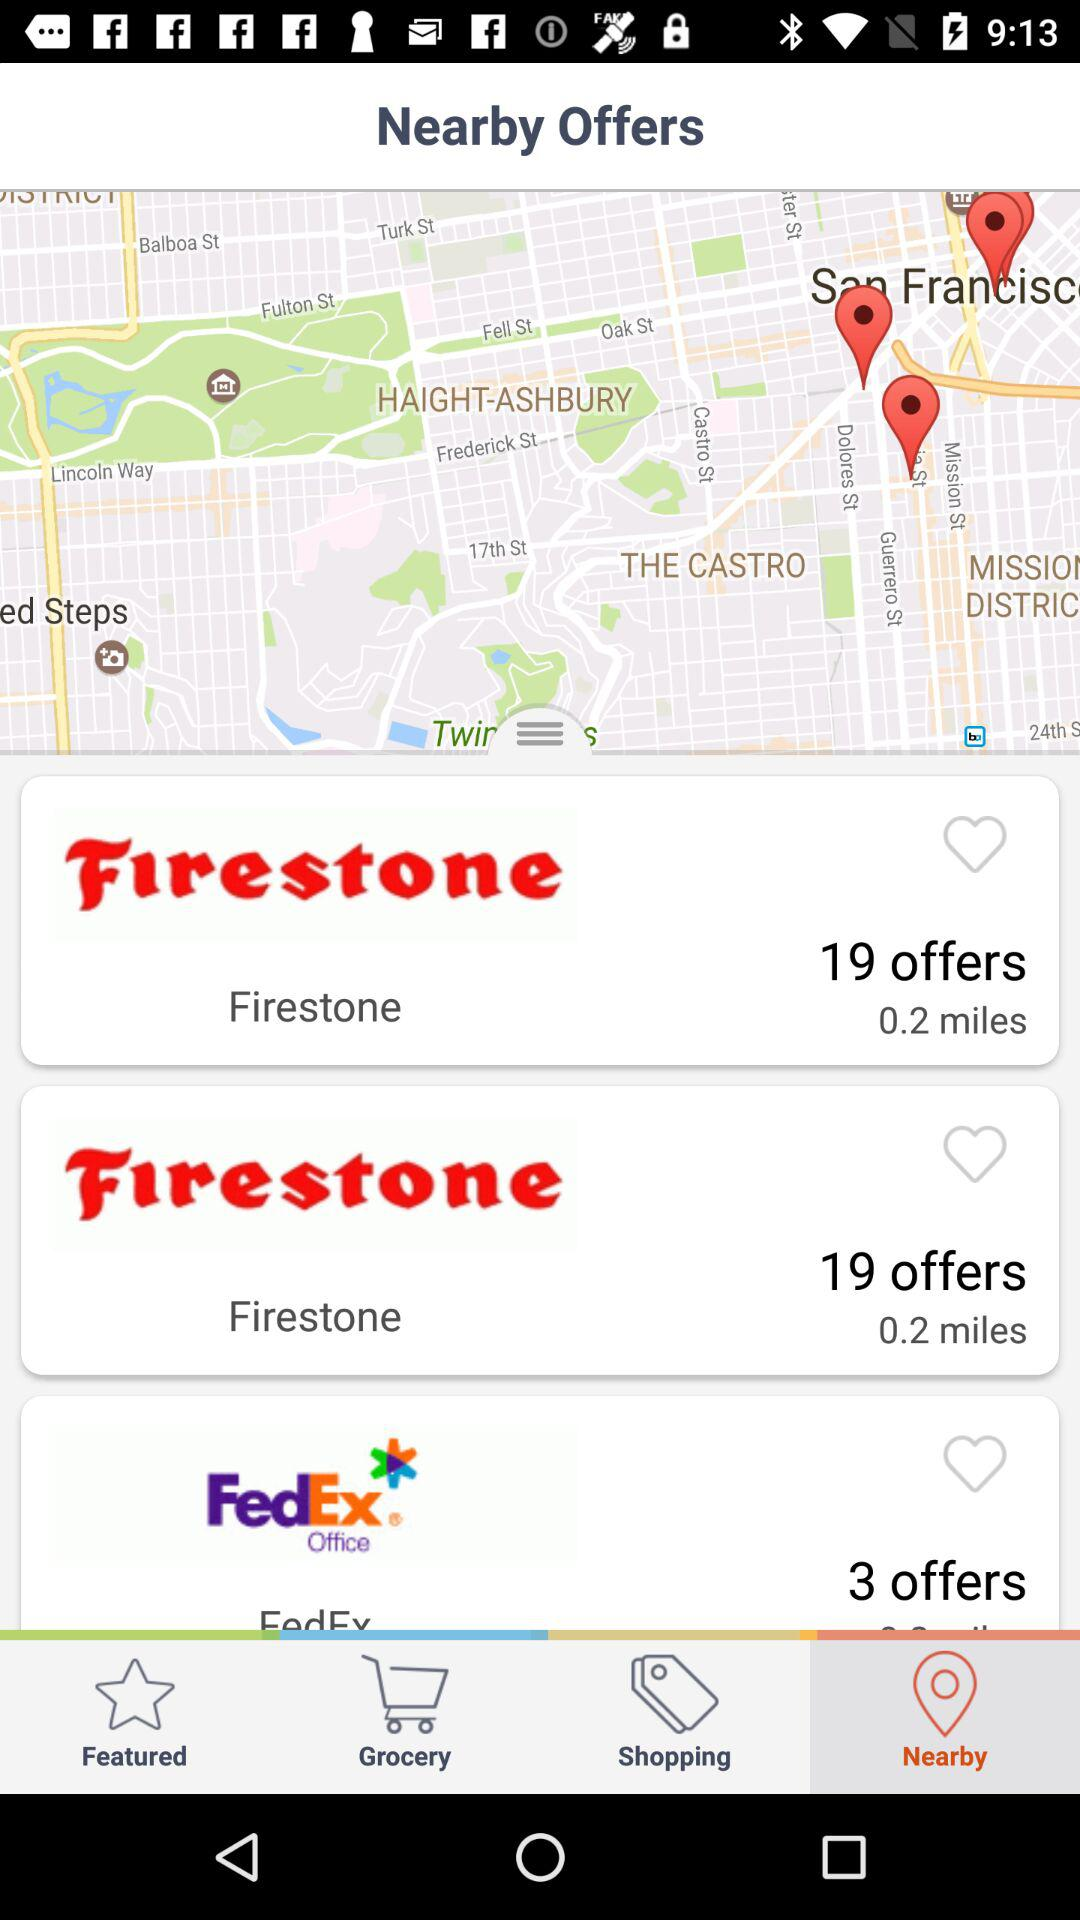What is on the grocery list?
When the provided information is insufficient, respond with <no answer>. <no answer> 